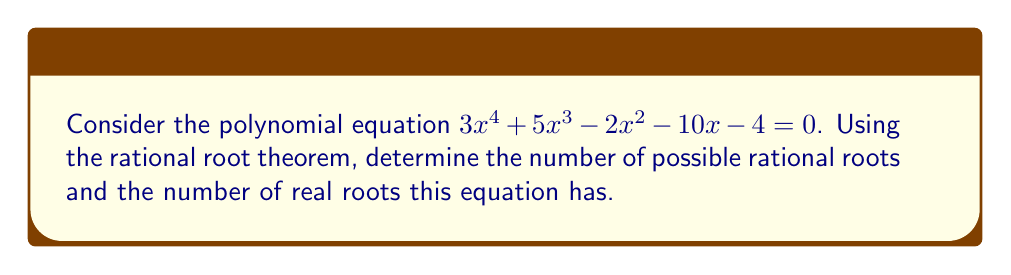Teach me how to tackle this problem. Let's approach this step-by-step:

1) First, we'll use the rational root theorem to find the possible rational roots.

   The possible rational roots are of the form $\pm \frac{p}{q}$, where $p$ is a factor of the constant term (4) and $q$ is a factor of the leading coefficient (3).

   Factors of 4: $\pm 1, \pm 2, \pm 4$
   Factors of 3: $\pm 1, \pm 3$

2) Therefore, the possible rational roots are:
   $$\pm 1, \pm 2, \pm 4, \pm \frac{1}{3}, \pm \frac{2}{3}, \pm \frac{4}{3}$$

   There are 12 possible rational roots.

3) To determine the number of real roots, we need to consider Descartes' Rule of Signs:

   For $f(x) = 3x^4 + 5x^3 - 2x^2 - 10x - 4$:
   Sign sequence: + + - - -
   Number of sign changes: 1

   For $f(-x) = 3x^4 - 5x^3 - 2x^2 + 10x - 4$:
   Sign sequence: + - - + -
   Number of sign changes: 3

4) Descartes' Rule of Signs states that the number of positive real roots is equal to the number of sign changes in $f(x)$ or less than it by an even number. The same applies for negative roots with $f(-x)$.

5) Therefore:
   - The number of positive real roots is 1
   - The number of negative real roots is either 3 or 1

6) In total, the polynomial has either 4 or 2 real roots.

7) Since the degree of the polynomial is 4, and complex roots always occur in conjugate pairs, we can conclude that this polynomial has 4 real roots.
Answer: 12 possible rational roots; 4 real roots 